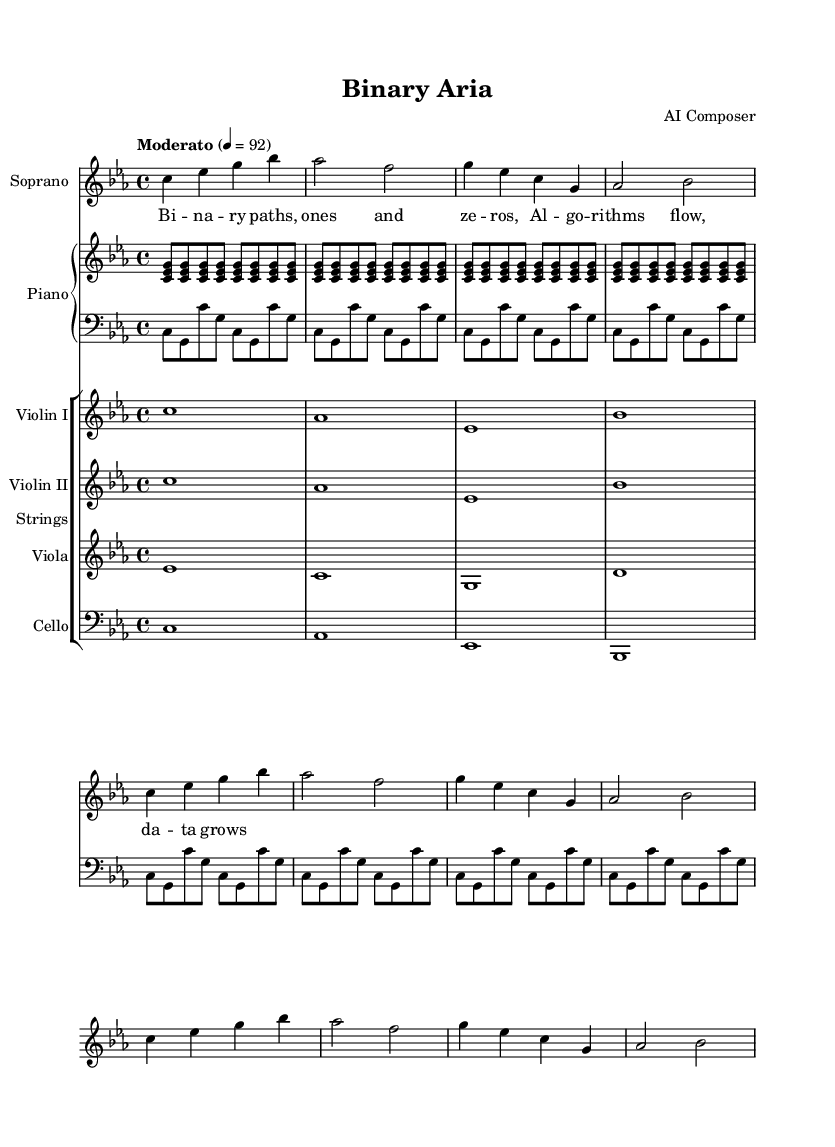What is the key signature of this music? The key signature is C minor, indicated by the presence of three flats in the score.
Answer: C minor What is the time signature of this music? The time signature is shown at the beginning of the score as 4/4, which indicates four beats per measure.
Answer: 4/4 What is the tempo marking for this piece? The tempo is indicated in the score as "Moderato," which suggests a moderate speed.
Answer: Moderato How many measures are in the soprano part? The soprano part includes a total of 10 measures, which can be counted visually from the start until the end of the section.
Answer: 10 What is the highest pitch utilized in the strings section? The highest pitch in the strings is indicated by the note B flat, which is found in the Violin I staff.
Answer: B flat Describe the style of the lyrics for the soprano part. The lyrics are repetitive and use simple language related to binary concepts, reflecting the minimalist style.
Answer: Repetitive and simple In how many times does the piano right hand repeat its pattern? The piano right hand repeats its pattern eight times throughout the piece, as indicated by the repeat sign.
Answer: Eight times 